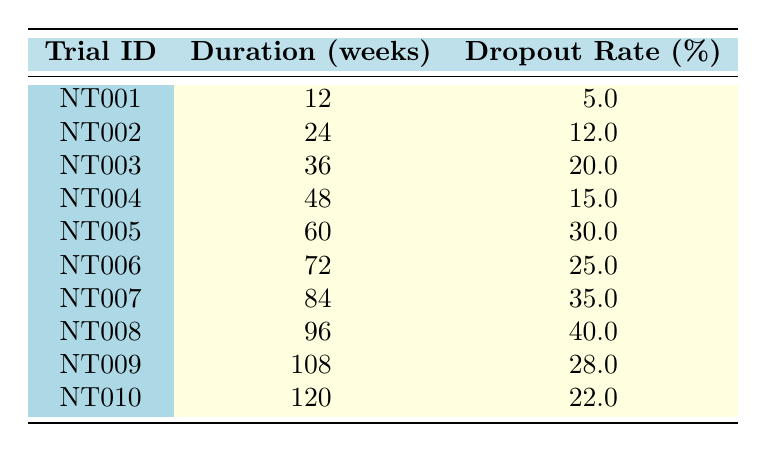What is the patient dropout rate for trial NT005? The table shows that the dropout rate for trial NT005 is specifically stated next to its entry. It lists a dropout rate of 30.0% for this trial.
Answer: 30.0% How many weeks is the longest trial duration? By inspecting the duration column in the table, the longest trial duration is found under trial NT010, which has a duration of 120 weeks.
Answer: 120 What is the average dropout rate for trials with a duration of 60 weeks or more? The trials with duration of 60 weeks or more are NT005, NT006, NT007, NT008, NT009, and NT010. The dropout rates for these trials are 30.0%, 25.0%, 35.0%, 40.0%, 28.0%, and 22.0%, respectively. Adding these gives 30.0 + 25.0 + 35.0 + 40.0 + 28.0 + 22.0 = 180.0. There are 6 trials, so the average dropout rate is 180.0 / 6 = 30.0%.
Answer: 30.0% Is the dropout rate for trial NT004 greater than 10%? The table indicates that the dropout rate for trial NT004 is 15.0%. Since 15.0% is greater than 10%, the statement is true.
Answer: Yes Which trial has the least patient dropout rate, and what is it? By reviewing the table, the patient dropout rates are listed. The lowest dropout rate is for trial NT001, which has a dropout rate of 5.0%.
Answer: NT001, 5.0% 